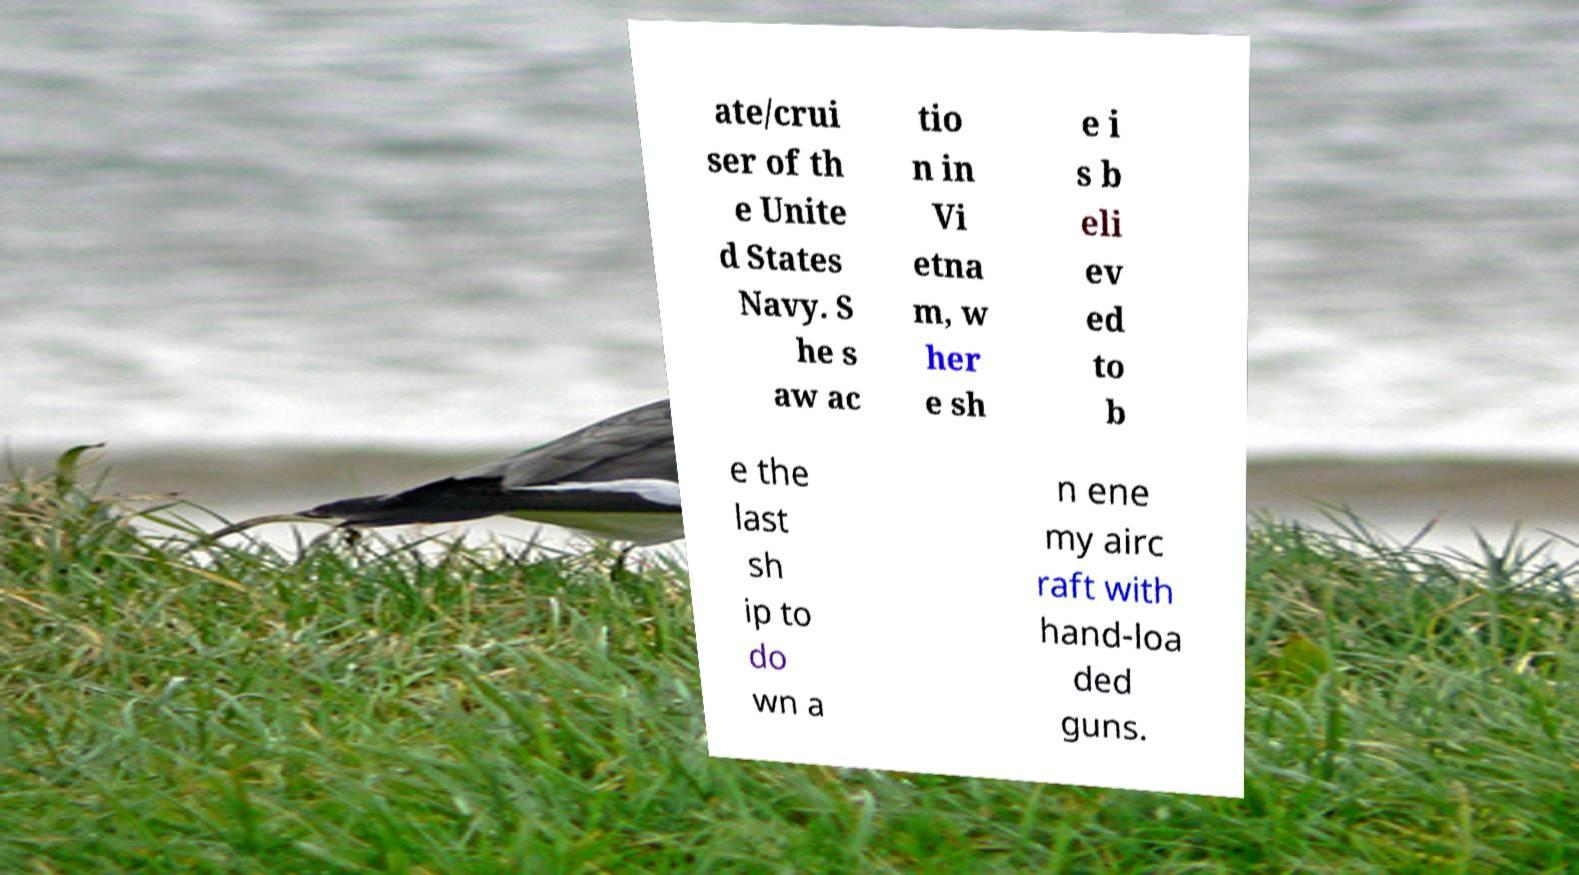For documentation purposes, I need the text within this image transcribed. Could you provide that? ate/crui ser of th e Unite d States Navy. S he s aw ac tio n in Vi etna m, w her e sh e i s b eli ev ed to b e the last sh ip to do wn a n ene my airc raft with hand-loa ded guns. 